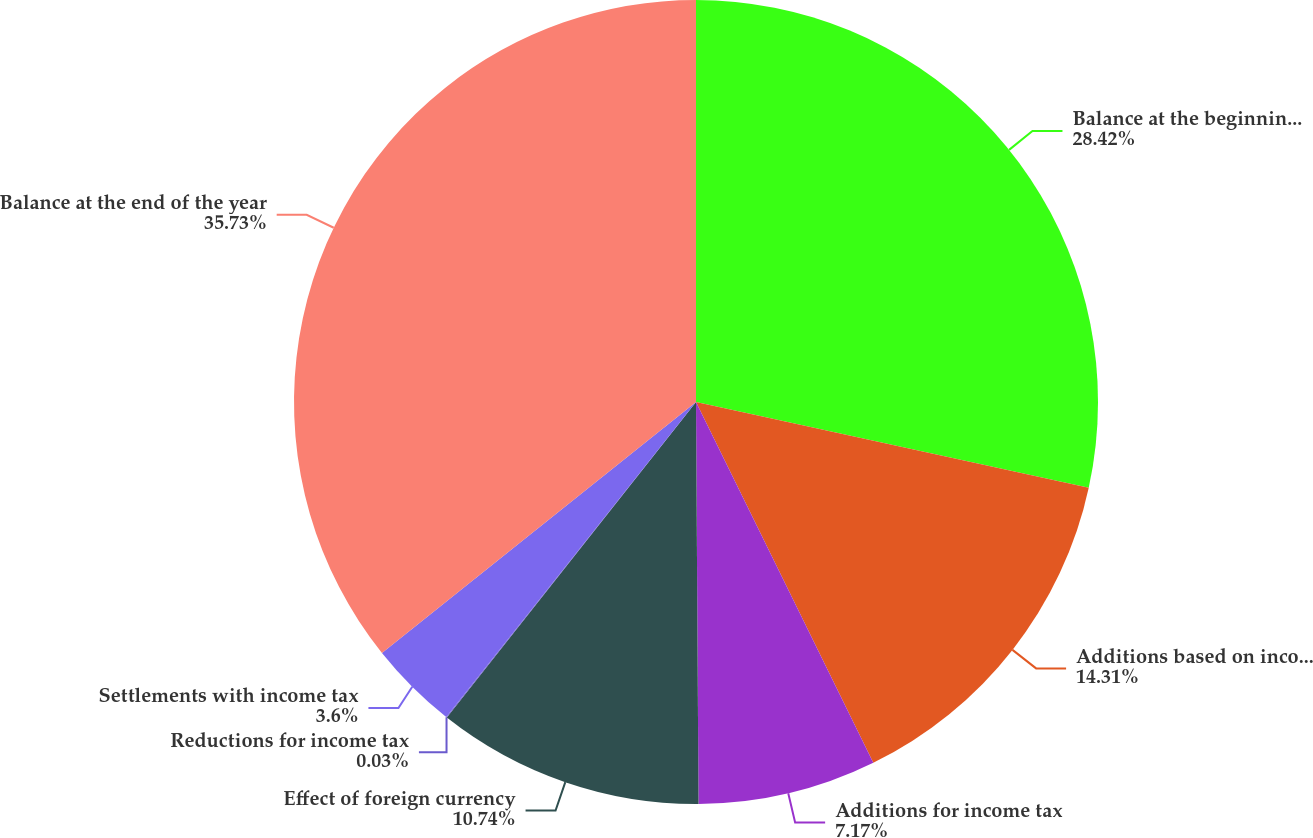Convert chart. <chart><loc_0><loc_0><loc_500><loc_500><pie_chart><fcel>Balance at the beginning of<fcel>Additions based on income tax<fcel>Additions for income tax<fcel>Effect of foreign currency<fcel>Reductions for income tax<fcel>Settlements with income tax<fcel>Balance at the end of the year<nl><fcel>28.42%<fcel>14.31%<fcel>7.17%<fcel>10.74%<fcel>0.03%<fcel>3.6%<fcel>35.73%<nl></chart> 